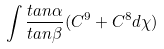Convert formula to latex. <formula><loc_0><loc_0><loc_500><loc_500>\int \frac { t a n \alpha } { t a n \beta } ( C ^ { 9 } + C ^ { 8 } d \chi )</formula> 